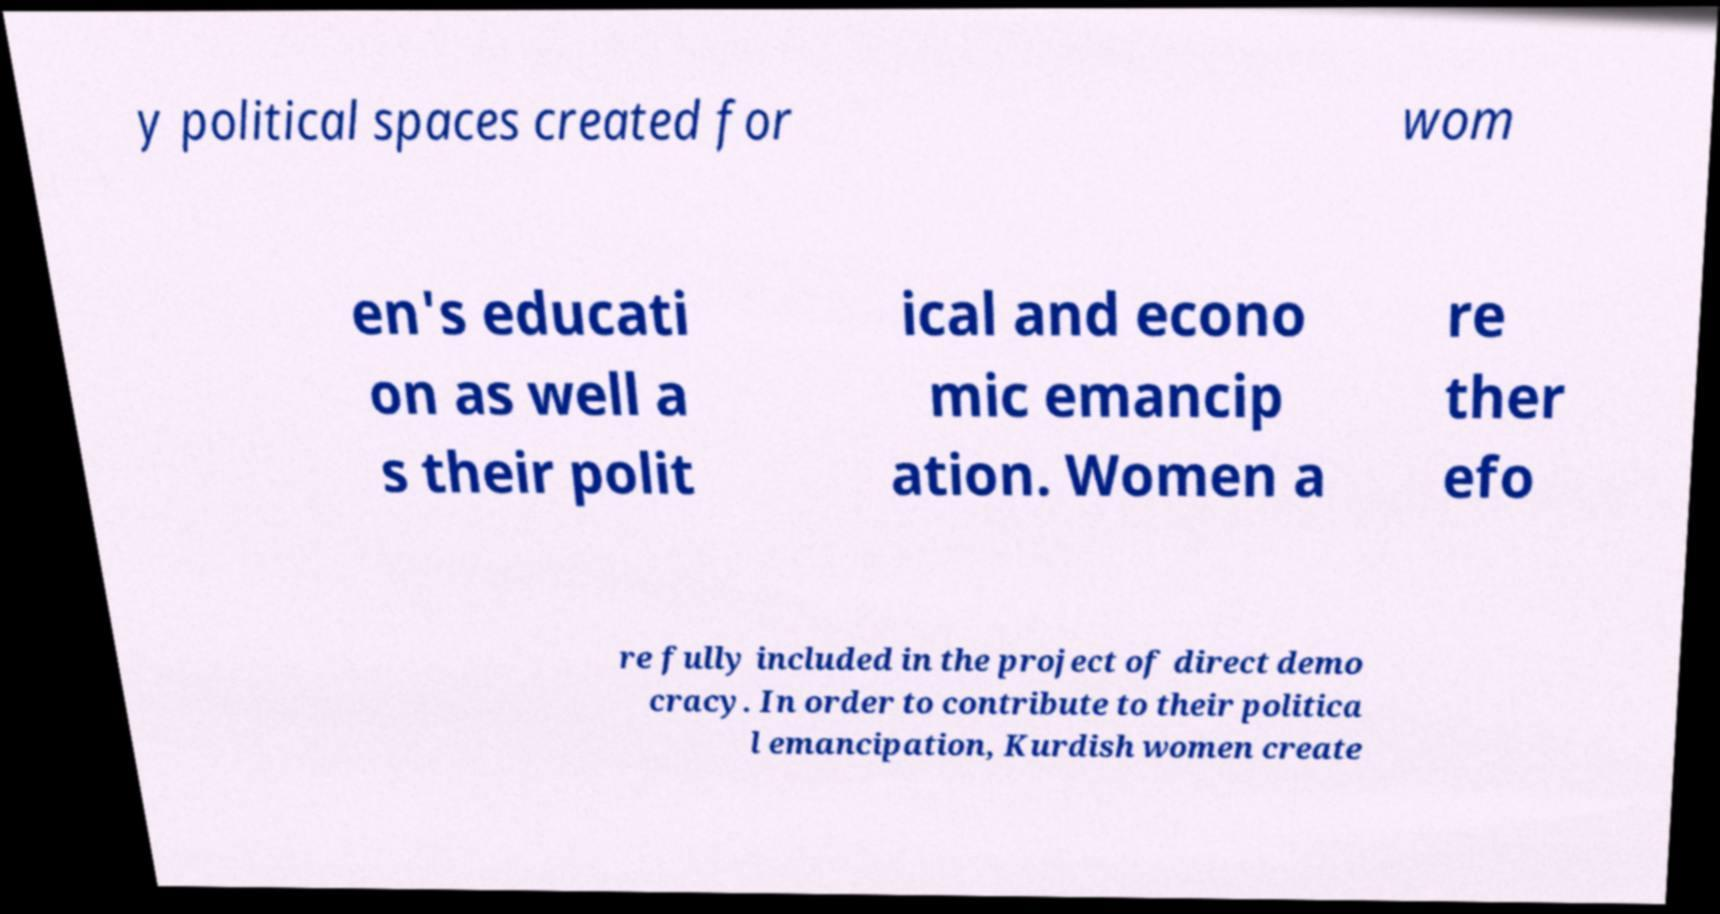Please read and relay the text visible in this image. What does it say? y political spaces created for wom en's educati on as well a s their polit ical and econo mic emancip ation. Women a re ther efo re fully included in the project of direct demo cracy. In order to contribute to their politica l emancipation, Kurdish women create 